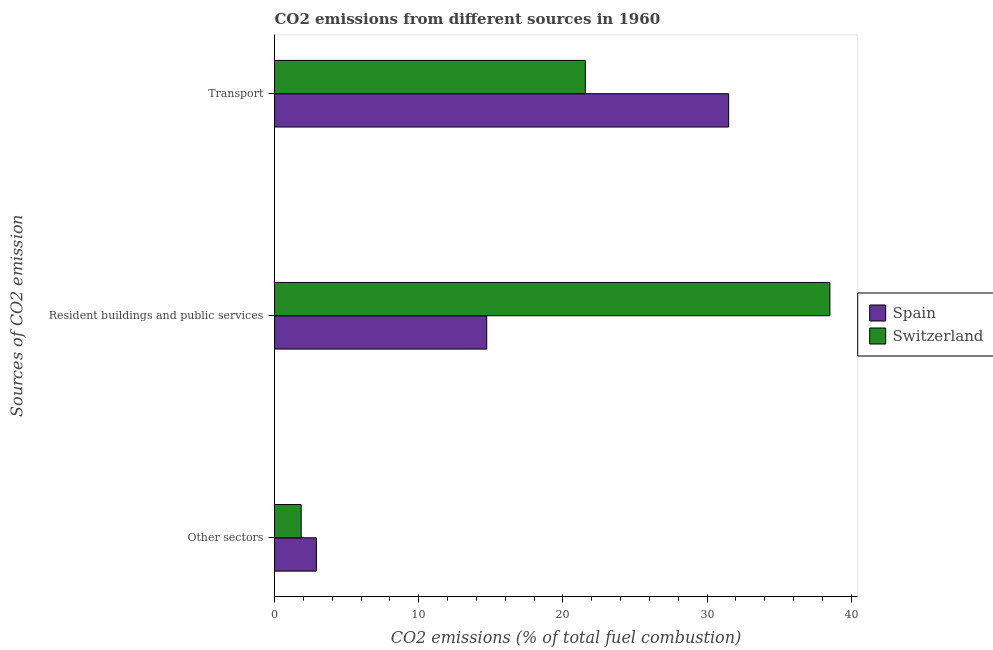How many groups of bars are there?
Offer a very short reply. 3. Are the number of bars on each tick of the Y-axis equal?
Your response must be concise. Yes. What is the label of the 1st group of bars from the top?
Ensure brevity in your answer.  Transport. What is the percentage of co2 emissions from transport in Switzerland?
Give a very brief answer. 21.56. Across all countries, what is the maximum percentage of co2 emissions from resident buildings and public services?
Offer a terse response. 38.52. Across all countries, what is the minimum percentage of co2 emissions from other sectors?
Provide a succinct answer. 1.85. In which country was the percentage of co2 emissions from transport minimum?
Give a very brief answer. Switzerland. What is the total percentage of co2 emissions from resident buildings and public services in the graph?
Provide a short and direct response. 53.24. What is the difference between the percentage of co2 emissions from resident buildings and public services in Switzerland and that in Spain?
Provide a succinct answer. 23.8. What is the difference between the percentage of co2 emissions from resident buildings and public services in Switzerland and the percentage of co2 emissions from other sectors in Spain?
Keep it short and to the point. 35.62. What is the average percentage of co2 emissions from resident buildings and public services per country?
Your answer should be compact. 26.62. What is the difference between the percentage of co2 emissions from resident buildings and public services and percentage of co2 emissions from transport in Spain?
Give a very brief answer. -16.78. In how many countries, is the percentage of co2 emissions from transport greater than 24 %?
Your response must be concise. 1. What is the ratio of the percentage of co2 emissions from resident buildings and public services in Switzerland to that in Spain?
Your answer should be very brief. 2.62. Is the percentage of co2 emissions from transport in Switzerland less than that in Spain?
Your answer should be very brief. Yes. Is the difference between the percentage of co2 emissions from other sectors in Spain and Switzerland greater than the difference between the percentage of co2 emissions from transport in Spain and Switzerland?
Make the answer very short. No. What is the difference between the highest and the second highest percentage of co2 emissions from resident buildings and public services?
Provide a succinct answer. 23.8. What is the difference between the highest and the lowest percentage of co2 emissions from other sectors?
Offer a terse response. 1.06. In how many countries, is the percentage of co2 emissions from transport greater than the average percentage of co2 emissions from transport taken over all countries?
Give a very brief answer. 1. Is the sum of the percentage of co2 emissions from resident buildings and public services in Switzerland and Spain greater than the maximum percentage of co2 emissions from other sectors across all countries?
Make the answer very short. Yes. What does the 1st bar from the top in Transport represents?
Give a very brief answer. Switzerland. Is it the case that in every country, the sum of the percentage of co2 emissions from other sectors and percentage of co2 emissions from resident buildings and public services is greater than the percentage of co2 emissions from transport?
Offer a very short reply. No. Does the graph contain any zero values?
Offer a terse response. No. Where does the legend appear in the graph?
Provide a short and direct response. Center right. What is the title of the graph?
Make the answer very short. CO2 emissions from different sources in 1960. Does "Virgin Islands" appear as one of the legend labels in the graph?
Your answer should be compact. No. What is the label or title of the X-axis?
Offer a terse response. CO2 emissions (% of total fuel combustion). What is the label or title of the Y-axis?
Provide a succinct answer. Sources of CO2 emission. What is the CO2 emissions (% of total fuel combustion) of Spain in Other sectors?
Give a very brief answer. 2.91. What is the CO2 emissions (% of total fuel combustion) in Switzerland in Other sectors?
Your answer should be very brief. 1.85. What is the CO2 emissions (% of total fuel combustion) of Spain in Resident buildings and public services?
Offer a terse response. 14.72. What is the CO2 emissions (% of total fuel combustion) in Switzerland in Resident buildings and public services?
Offer a very short reply. 38.52. What is the CO2 emissions (% of total fuel combustion) of Spain in Transport?
Your answer should be very brief. 31.5. What is the CO2 emissions (% of total fuel combustion) of Switzerland in Transport?
Ensure brevity in your answer.  21.56. Across all Sources of CO2 emission, what is the maximum CO2 emissions (% of total fuel combustion) in Spain?
Provide a succinct answer. 31.5. Across all Sources of CO2 emission, what is the maximum CO2 emissions (% of total fuel combustion) in Switzerland?
Give a very brief answer. 38.52. Across all Sources of CO2 emission, what is the minimum CO2 emissions (% of total fuel combustion) of Spain?
Your answer should be very brief. 2.91. Across all Sources of CO2 emission, what is the minimum CO2 emissions (% of total fuel combustion) in Switzerland?
Provide a succinct answer. 1.85. What is the total CO2 emissions (% of total fuel combustion) in Spain in the graph?
Offer a very short reply. 49.12. What is the total CO2 emissions (% of total fuel combustion) of Switzerland in the graph?
Provide a short and direct response. 61.93. What is the difference between the CO2 emissions (% of total fuel combustion) of Spain in Other sectors and that in Resident buildings and public services?
Provide a succinct answer. -11.81. What is the difference between the CO2 emissions (% of total fuel combustion) of Switzerland in Other sectors and that in Resident buildings and public services?
Your answer should be very brief. -36.67. What is the difference between the CO2 emissions (% of total fuel combustion) of Spain in Other sectors and that in Transport?
Your response must be concise. -28.59. What is the difference between the CO2 emissions (% of total fuel combustion) in Switzerland in Other sectors and that in Transport?
Provide a short and direct response. -19.71. What is the difference between the CO2 emissions (% of total fuel combustion) of Spain in Resident buildings and public services and that in Transport?
Offer a very short reply. -16.78. What is the difference between the CO2 emissions (% of total fuel combustion) of Switzerland in Resident buildings and public services and that in Transport?
Your answer should be very brief. 16.97. What is the difference between the CO2 emissions (% of total fuel combustion) in Spain in Other sectors and the CO2 emissions (% of total fuel combustion) in Switzerland in Resident buildings and public services?
Offer a terse response. -35.62. What is the difference between the CO2 emissions (% of total fuel combustion) in Spain in Other sectors and the CO2 emissions (% of total fuel combustion) in Switzerland in Transport?
Offer a terse response. -18.65. What is the difference between the CO2 emissions (% of total fuel combustion) of Spain in Resident buildings and public services and the CO2 emissions (% of total fuel combustion) of Switzerland in Transport?
Offer a terse response. -6.84. What is the average CO2 emissions (% of total fuel combustion) of Spain per Sources of CO2 emission?
Offer a terse response. 16.37. What is the average CO2 emissions (% of total fuel combustion) of Switzerland per Sources of CO2 emission?
Your answer should be compact. 20.64. What is the difference between the CO2 emissions (% of total fuel combustion) of Spain and CO2 emissions (% of total fuel combustion) of Switzerland in Other sectors?
Ensure brevity in your answer.  1.06. What is the difference between the CO2 emissions (% of total fuel combustion) in Spain and CO2 emissions (% of total fuel combustion) in Switzerland in Resident buildings and public services?
Give a very brief answer. -23.8. What is the difference between the CO2 emissions (% of total fuel combustion) of Spain and CO2 emissions (% of total fuel combustion) of Switzerland in Transport?
Provide a succinct answer. 9.94. What is the ratio of the CO2 emissions (% of total fuel combustion) of Spain in Other sectors to that in Resident buildings and public services?
Keep it short and to the point. 0.2. What is the ratio of the CO2 emissions (% of total fuel combustion) of Switzerland in Other sectors to that in Resident buildings and public services?
Your response must be concise. 0.05. What is the ratio of the CO2 emissions (% of total fuel combustion) in Spain in Other sectors to that in Transport?
Make the answer very short. 0.09. What is the ratio of the CO2 emissions (% of total fuel combustion) of Switzerland in Other sectors to that in Transport?
Ensure brevity in your answer.  0.09. What is the ratio of the CO2 emissions (% of total fuel combustion) of Spain in Resident buildings and public services to that in Transport?
Provide a short and direct response. 0.47. What is the ratio of the CO2 emissions (% of total fuel combustion) of Switzerland in Resident buildings and public services to that in Transport?
Provide a succinct answer. 1.79. What is the difference between the highest and the second highest CO2 emissions (% of total fuel combustion) in Spain?
Make the answer very short. 16.78. What is the difference between the highest and the second highest CO2 emissions (% of total fuel combustion) in Switzerland?
Ensure brevity in your answer.  16.97. What is the difference between the highest and the lowest CO2 emissions (% of total fuel combustion) of Spain?
Ensure brevity in your answer.  28.59. What is the difference between the highest and the lowest CO2 emissions (% of total fuel combustion) of Switzerland?
Give a very brief answer. 36.67. 